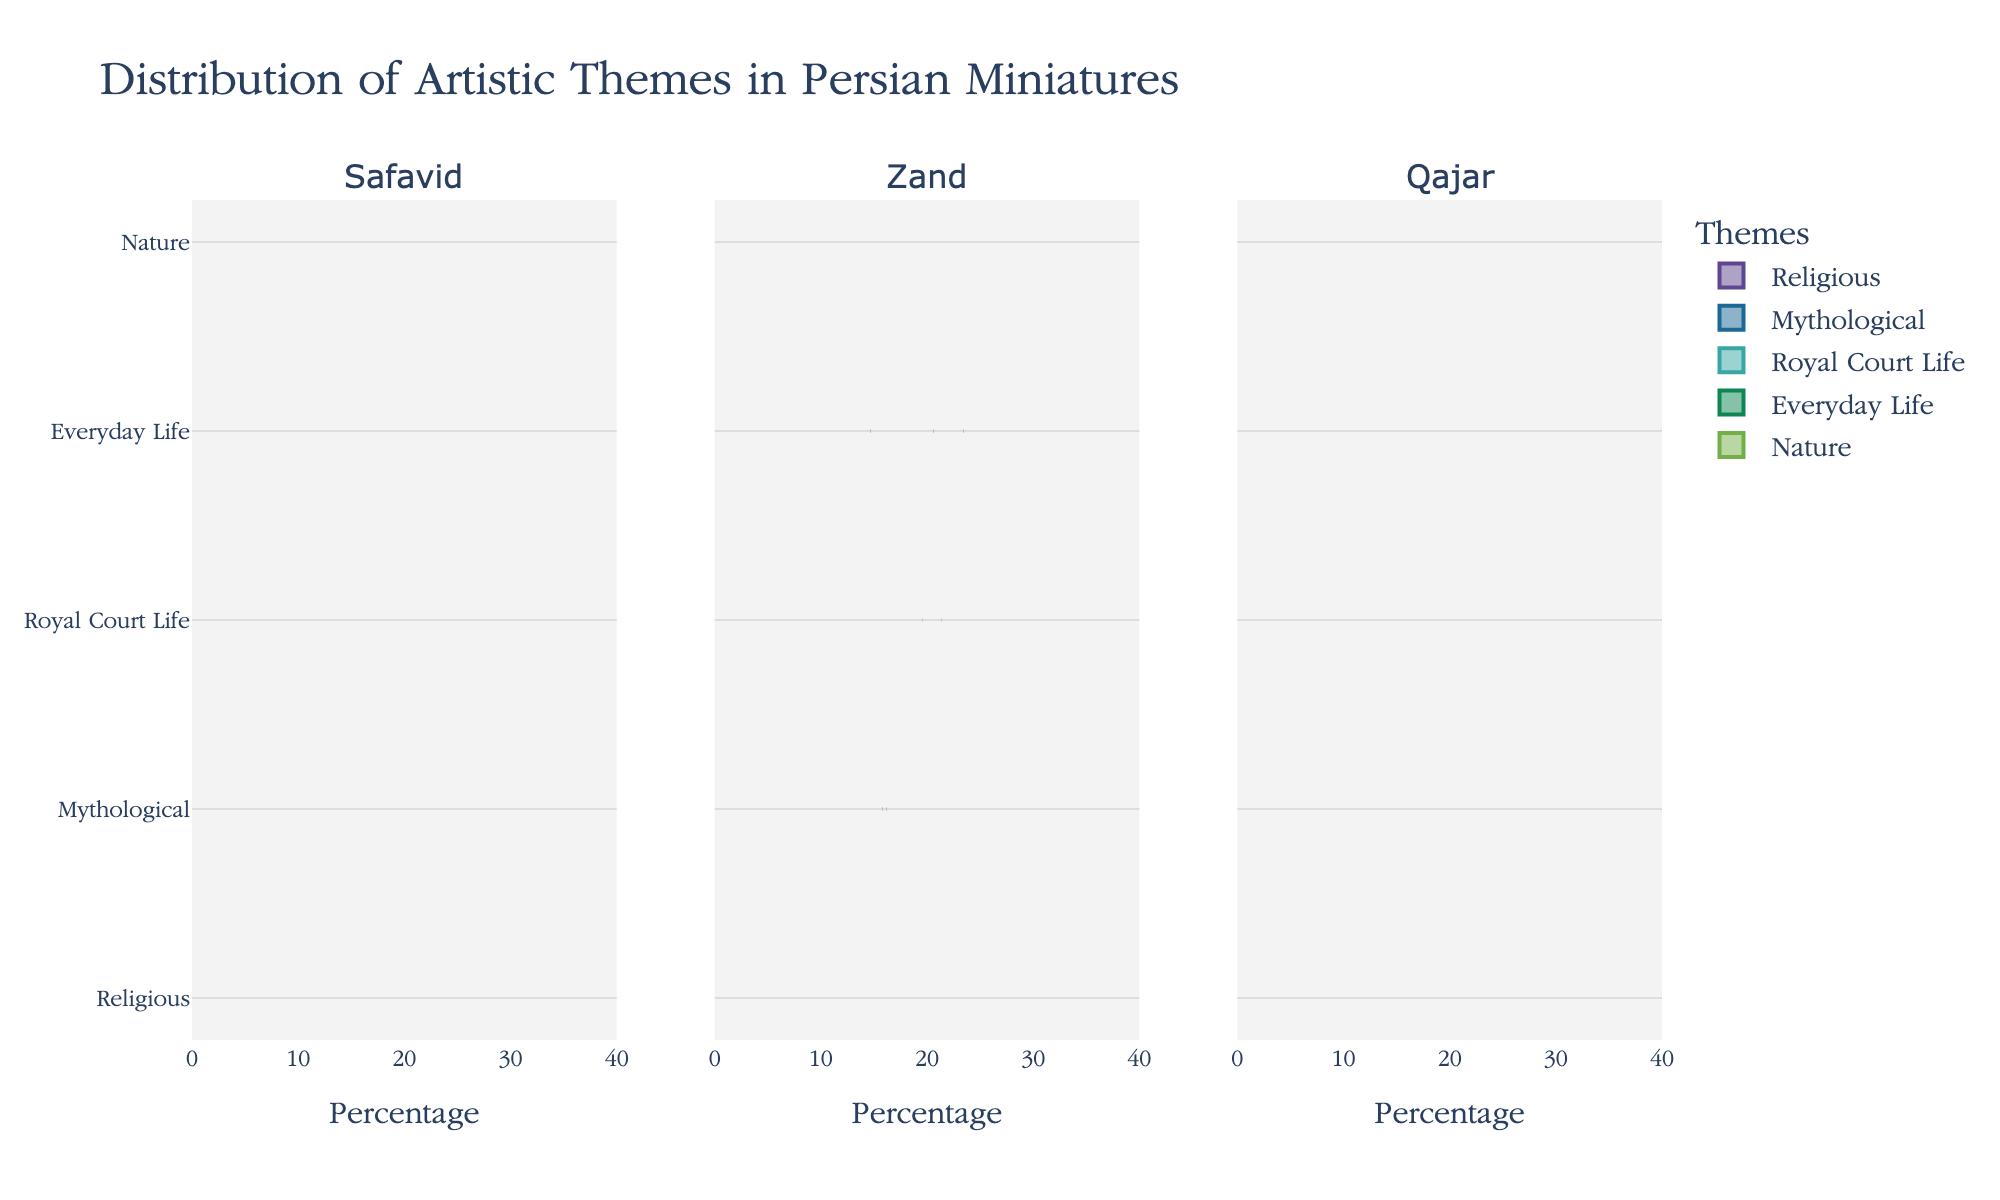What is the title of the figure? The title is displayed at the top of the figure. It summarizes the main focus of the visualization.
Answer: Distribution of Artistic Themes in Persian Miniatures Which period depicts the highest percentage of religious themes? By looking at the density and central tendency of the religious theme in each period, one can see which period has the highest value.
Answer: Zand How does the representation of mythological themes change from the Safavid period to the Qajar period? Compare the densities and central values of the mythological themes for both periods. Safavid has 20%, and Qajar has 25%, indicating an increase.
Answer: Increase What is the combined percentage of Royal Court Life themes across all periods? Sum the percentages of Royal Court Life themes for Safavid, Zand, and Qajar periods: 30% (Safavid) + 20% (Zand) + 15% (Qajar).
Answer: 65% Rank the periods in descending order of their representation of Everyday Life themes. Compare the densities for Everyday Life across the periods: Qajar (25%), Zand (20%), Safavid (15%). Arranging them in descending order gives Qajar, Zand, Safavid.
Answer: Qajar, Zand, Safavid In which period does the nature theme have the least representation? Look at the violin plots and their central tendency for the nature theme across all periods.
Answer: Safavid Which themes show an equal percentage distribution in the Qajar period? In Qajar, observe the themes plotted to find themes with matching percentages. Both Everyday Life and Religious themes are at 25%.
Answer: Everyday Life and Nature How does the range of percentages for mythological themes compare between the Zand and Qajar periods? Compare the spread of the violin plots for mythological themes in both periods. Zand is centered around 15%, while Qajar is around 25%.
Answer: Qajar > Zand What trend do you observe in the representation of religious themes from the Safavid to the Qajar periods? Evaluate the density plots for religious themes over the three periods. Safavid starts at 25%, Zand increases to 30%, and Qajar drops to 20%.
Answer: Increases then decreases 